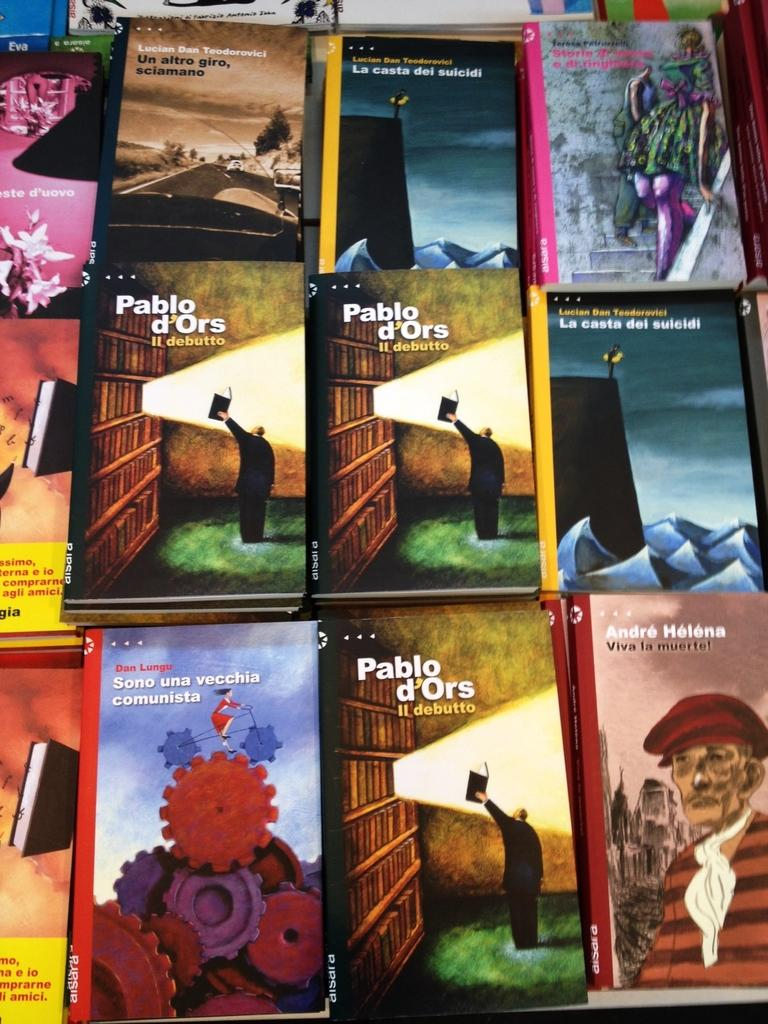What objects are present on the table in the image? There are many books and a few images on the table. What can be found on the books? The books have text on them. How many dogs are wearing a scarf in the image? There are no dogs or scarves present in the image. 